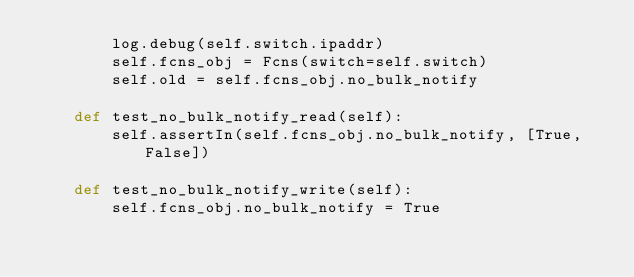<code> <loc_0><loc_0><loc_500><loc_500><_Python_>        log.debug(self.switch.ipaddr)
        self.fcns_obj = Fcns(switch=self.switch)
        self.old = self.fcns_obj.no_bulk_notify

    def test_no_bulk_notify_read(self):
        self.assertIn(self.fcns_obj.no_bulk_notify, [True, False])

    def test_no_bulk_notify_write(self):
        self.fcns_obj.no_bulk_notify = True</code> 